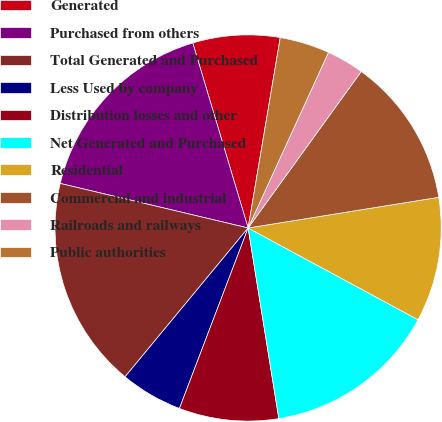Convert chart. <chart><loc_0><loc_0><loc_500><loc_500><pie_chart><fcel>Generated<fcel>Purchased from others<fcel>Total Generated and Purchased<fcel>Less Used by company<fcel>Distribution losses and other<fcel>Net Generated and Purchased<fcel>Residential<fcel>Commercial and industrial<fcel>Railroads and railways<fcel>Public authorities<nl><fcel>7.29%<fcel>16.67%<fcel>17.71%<fcel>5.21%<fcel>8.33%<fcel>14.58%<fcel>10.42%<fcel>12.5%<fcel>3.13%<fcel>4.17%<nl></chart> 